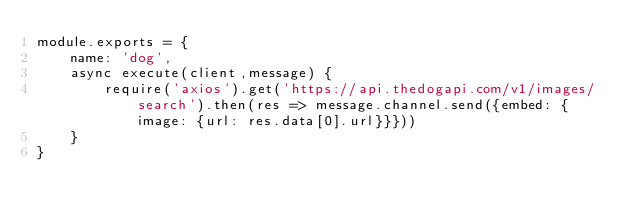Convert code to text. <code><loc_0><loc_0><loc_500><loc_500><_JavaScript_>module.exports = {
    name: 'dog',
    async execute(client,message) {
        require('axios').get('https://api.thedogapi.com/v1/images/search').then(res => message.channel.send({embed: {image: {url: res.data[0].url}}}))
    }
}</code> 